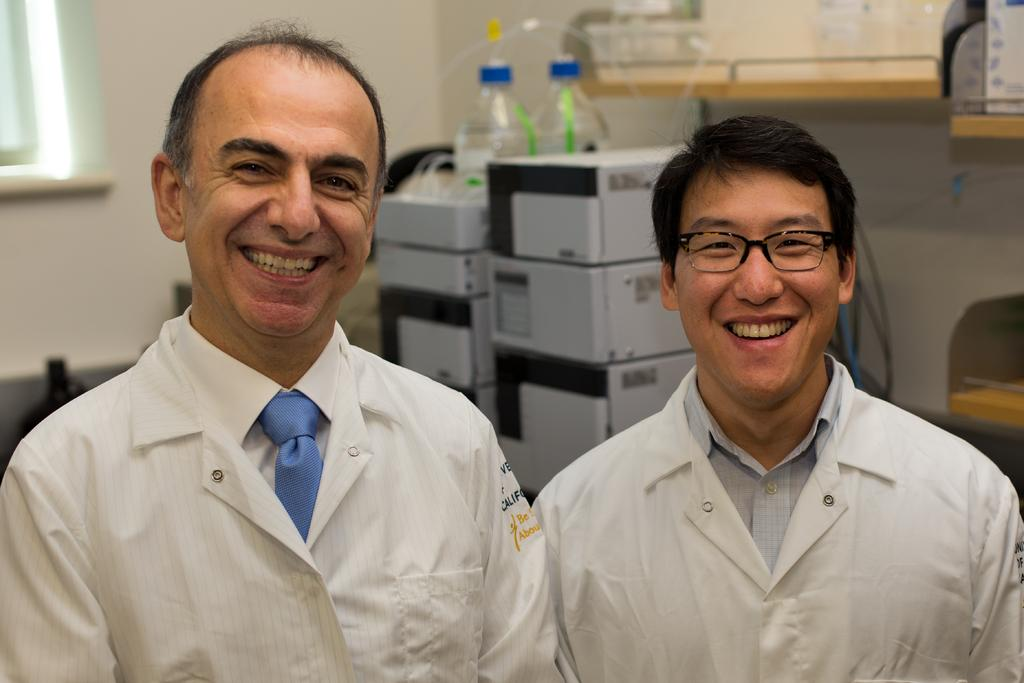How many men are present in the image? There are two men in the image. What is the facial expression of the men? Both men are smiling. Can you describe one of the men's appearance? One of the men is wearing spectacles. What can be seen in the background of the image? There are boxes, bottles, a wall, and other objects visible in the background of the image. What type of screw can be seen in the image? There is no screw present in the image. How much waste is visible in the image? There is no waste visible in the image. What is the debt situation of the men in the image? There is no information about the men's debt situation in the image. 